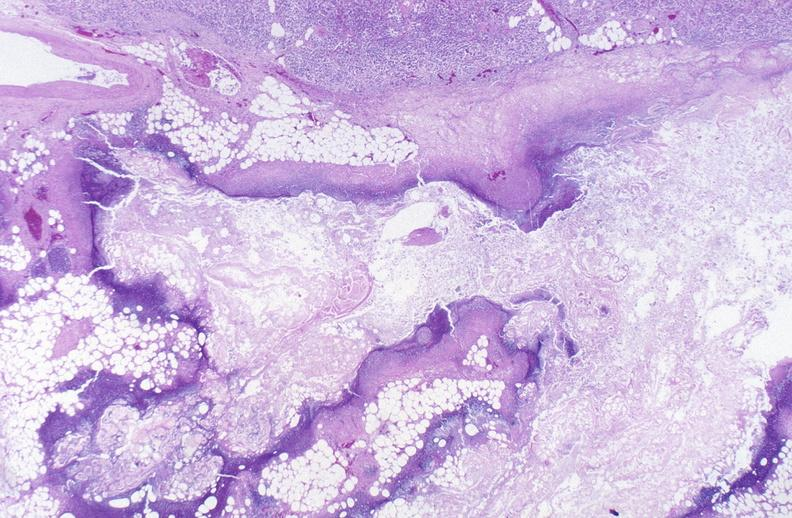where is this?
Answer the question using a single word or phrase. Pancreas 